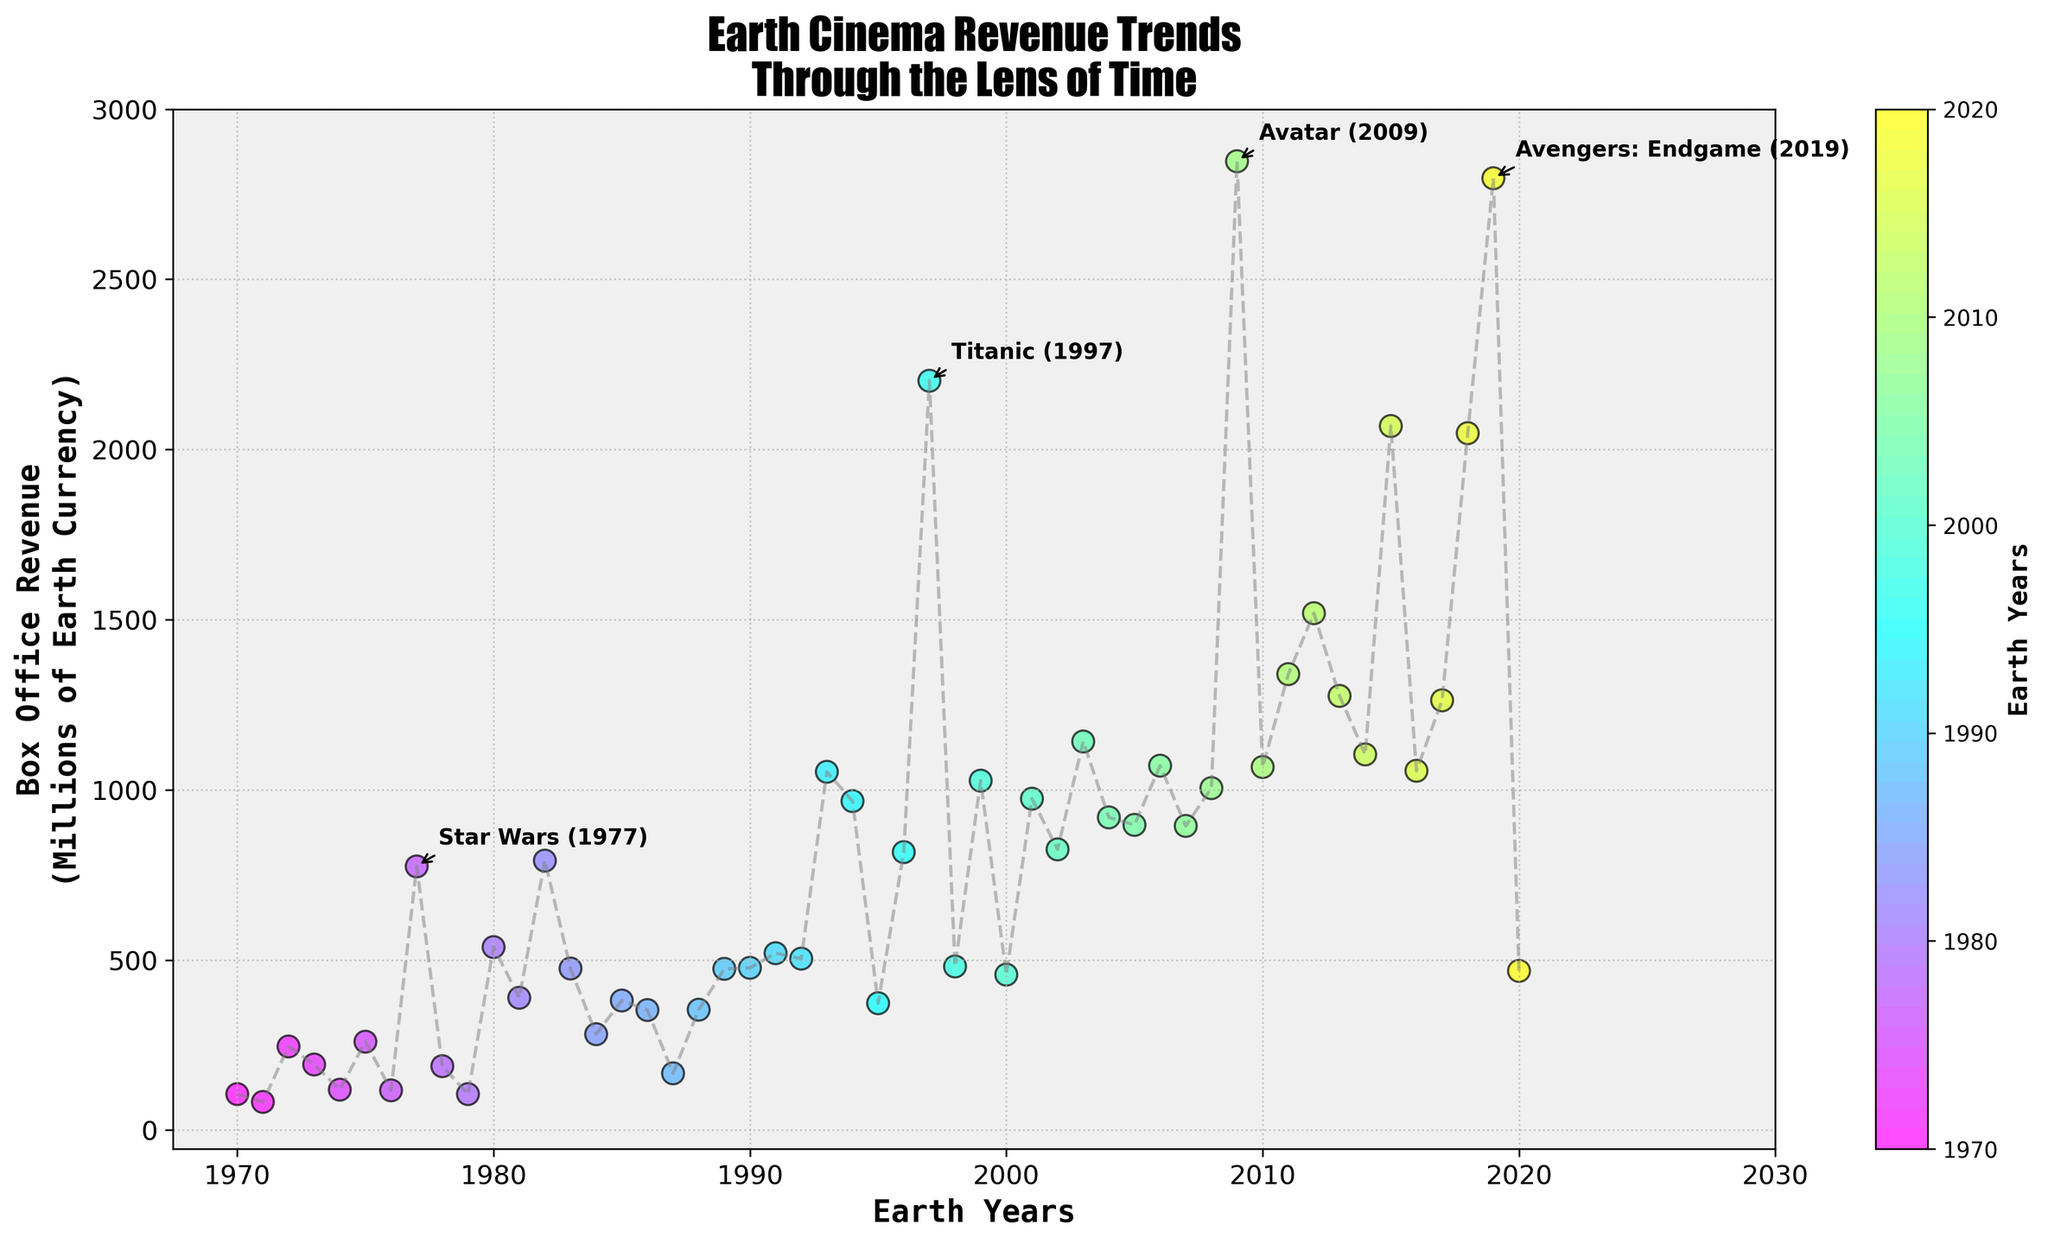what is the title of the plot? The title is located at the top of the plot and can be easily read.
Answer: Earth Cinema Revenue Trends Through the Lens of Time What year had the highest box office revenue according to the plot? By observing the highest point on the y-axis, we can find the peak value and read the corresponding year from the x-axis.
Answer: 2009 How does the box office revenue trend change from 1970 to 2020? Looking at the overall scatter plot, we can observe that the general trend of the revenue points increases with time. The revenues are usually higher in the later years compared to the earlier ones.
Answer: Overall increase Which movie had the highest box office revenue in the year 1997? By locating the year 1997 on the x-axis and identifying the point on the plot, we can find the corresponding movie annotated at that point.
Answer: Titanic What are the exact box office revenues for the years 1977, 1993, and 2019? Locate the specific years on the x-axis, read the corresponding points for those years and note the revenue values annotated.
Answer: 775, 1053, 2797 Which two movies have the closest box office revenue values within the plot? By comparing nearby points on the y-axis, we can identify the closest revenue values and then read their respective movie titles from the annotations.
Answer: Terminator 2 and Aladdin (both near 500 million) How many years is the gap between the highest revenue movie and the lowest revenue movie in the annotated points? Identify the years of highest and lowest revenue annotative points and calculate the difference.
Answer: 49 years (2009 - 1970) Which movie achieved a higher box office revenue, 'Star Wars: The Force Awakens' (2015) or 'Avengers: Endgame' (2019)? By comparing their respective revenue points on the y-axis, it is clear which one is higher.
Answer: Avengers: Endgame What type of trend can be observed for movie revenues from 2010 to 2020? Observing the points from the year 2010 through 2020 reveals whether the revenues are increasing, decreasing, or fluctuating.
Answer: Fluctuating with an overall increase Count the number of movies that had a box office revenue of over 1000 million. Counting all the points above the 1000 million mark on the y-axis gives the total number.
Answer: Eight movies 